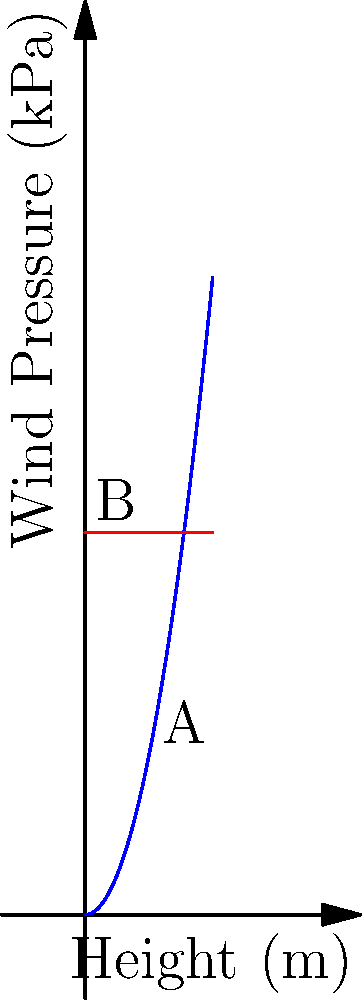A 30-story high-rise building is being constructed in a coastal area. The wind pressure on the building increases quadratically with height, following the function $p(h) = 0.5h^2$, where $p$ is the wind pressure in kPa and $h$ is the height in meters. What is the total wind load on the building if each story is 3 meters tall and the building has a constant width of 25 meters? To solve this problem, we'll follow these steps:

1. Calculate the total height of the building:
   $H = 30 \text{ stories} \times 3 \text{ m/story} = 90 \text{ m}$

2. Set up the integral to calculate the total wind load:
   $\text{Total Load} = \int_0^H w \cdot p(h) \, dh$
   where $w$ is the width of the building

3. Substitute the given function and values:
   $\text{Total Load} = \int_0^{90} 25 \cdot (0.5h^2) \, dh$

4. Simplify and solve the integral:
   $\text{Total Load} = 25 \cdot 0.5 \int_0^{90} h^2 \, dh$
   $= 12.5 \cdot [\frac{1}{3}h^3]_0^{90}$
   $= 12.5 \cdot (\frac{1}{3} \cdot 90^3 - 0)$
   $= 12.5 \cdot \frac{729000}{3}$
   $= 3037500 \text{ kN}$

5. Convert to MN for a more manageable unit:
   $\text{Total Load} = 3037.5 \text{ MN}$
Answer: 3037.5 MN 